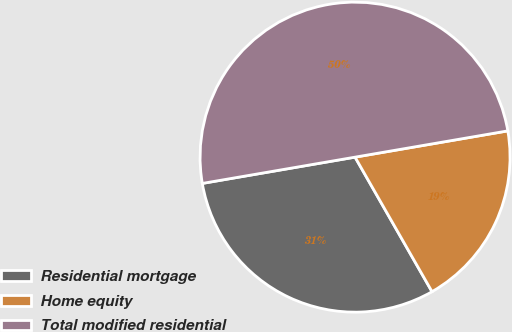<chart> <loc_0><loc_0><loc_500><loc_500><pie_chart><fcel>Residential mortgage<fcel>Home equity<fcel>Total modified residential<nl><fcel>30.56%<fcel>19.44%<fcel>50.0%<nl></chart> 